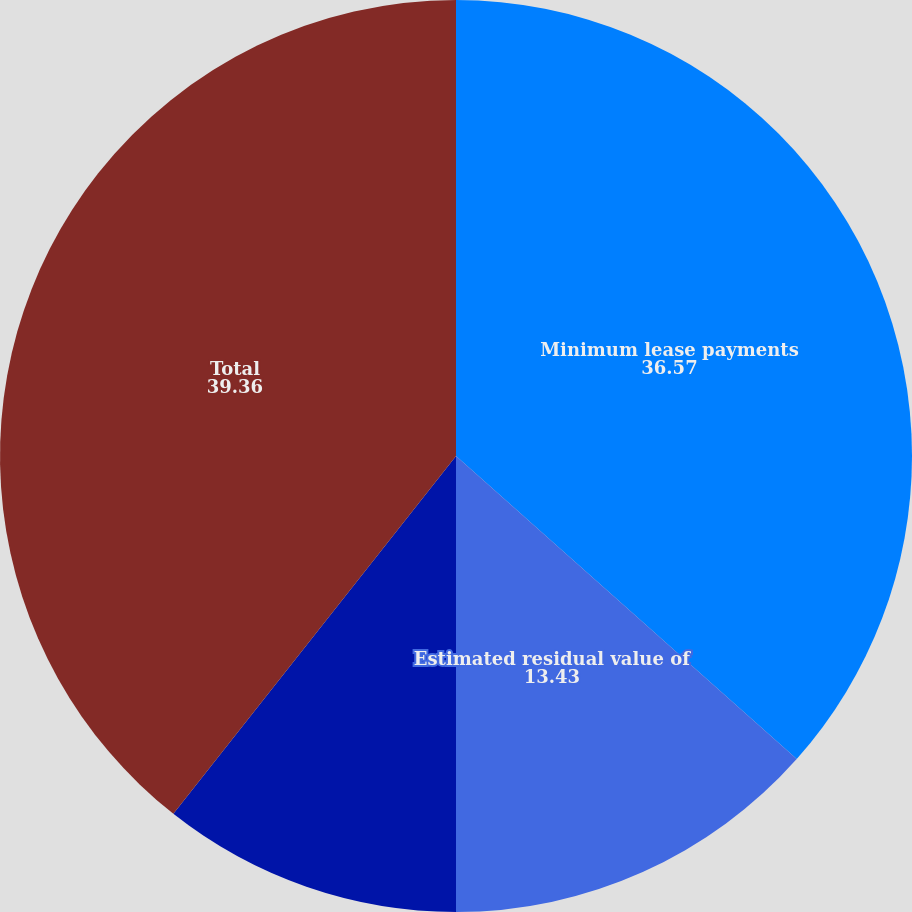<chart> <loc_0><loc_0><loc_500><loc_500><pie_chart><fcel>Minimum lease payments<fcel>Estimated residual value of<fcel>Unearned income<fcel>Total<nl><fcel>36.57%<fcel>13.43%<fcel>10.64%<fcel>39.36%<nl></chart> 